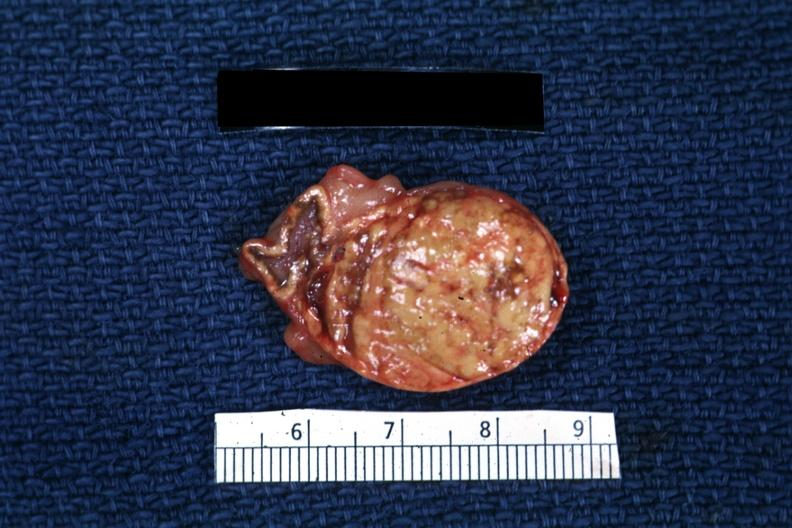what is present?
Answer the question using a single word or phrase. Adrenal 